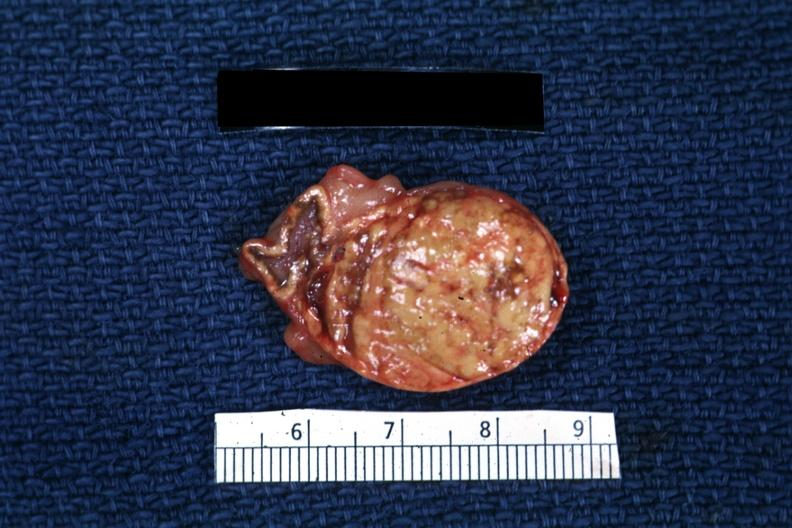what is present?
Answer the question using a single word or phrase. Adrenal 